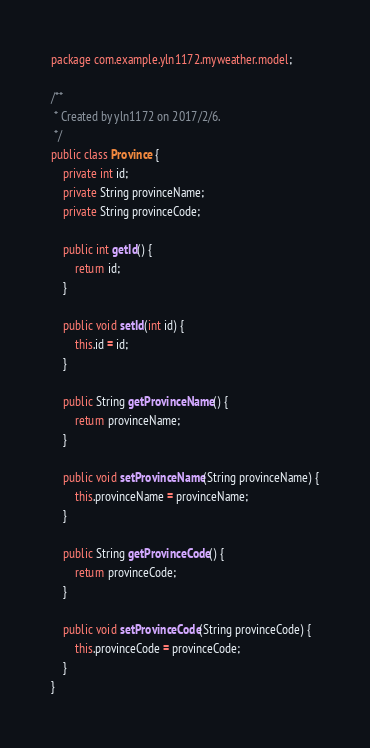<code> <loc_0><loc_0><loc_500><loc_500><_Java_>package com.example.yln1172.myweather.model;

/**
 * Created by yln1172 on 2017/2/6.
 */
public class Province {
    private int id;
    private String provinceName;
    private String provinceCode;

    public int getId() {
        return id;
    }

    public void setId(int id) {
        this.id = id;
    }

    public String getProvinceName() {
        return provinceName;
    }

    public void setProvinceName(String provinceName) {
        this.provinceName = provinceName;
    }

    public String getProvinceCode() {
        return provinceCode;
    }

    public void setProvinceCode(String provinceCode) {
        this.provinceCode = provinceCode;
    }
}
</code> 